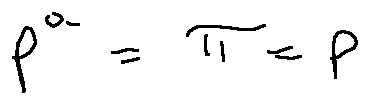Convert formula to latex. <formula><loc_0><loc_0><loc_500><loc_500>p ^ { a } = \pi = p</formula> 